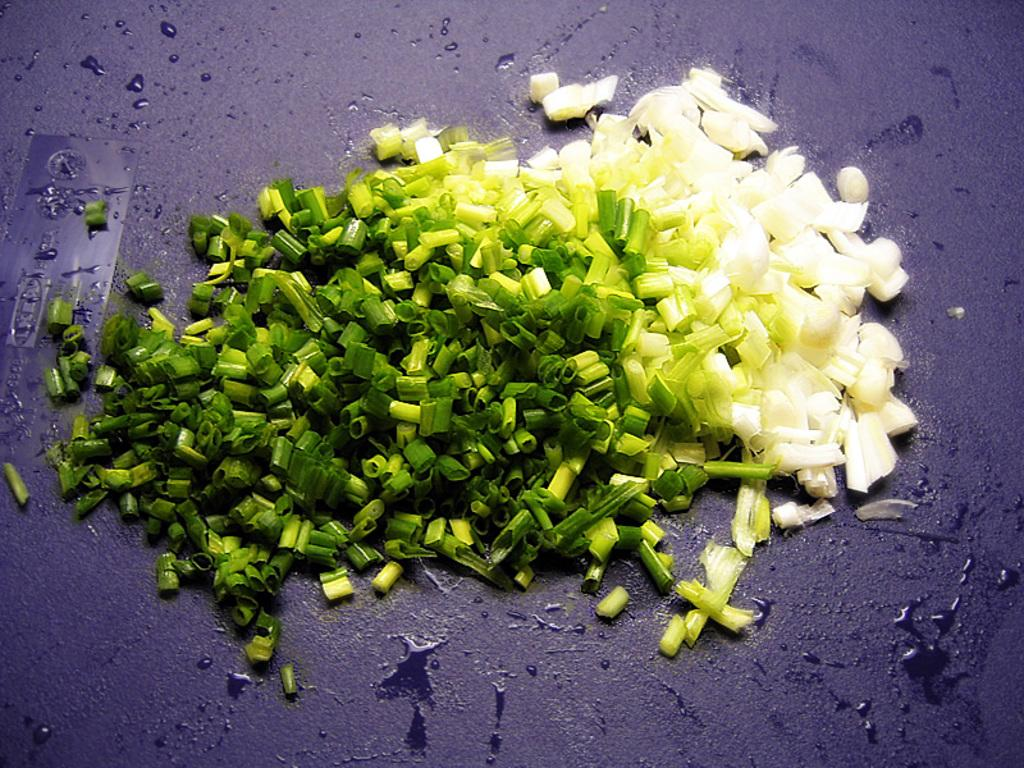What type of food can be seen in the image? There are vegetables in the image. What is the color of the surface on which the vegetables are placed? The vegetables are on a gray color surface. What colors can be observed on the vegetables themselves? The vegetables have white and green colors. How many books are stacked on the edge of the surface in the image? There are no books present in the image; it only features vegetables on a gray color surface. 